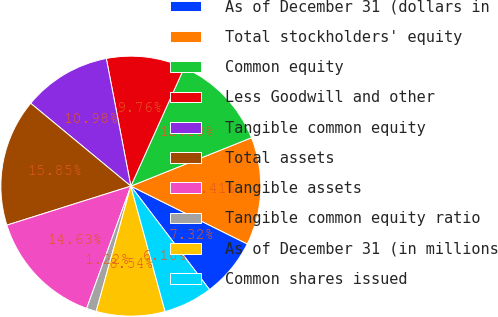Convert chart to OTSL. <chart><loc_0><loc_0><loc_500><loc_500><pie_chart><fcel>As of December 31 (dollars in<fcel>Total stockholders' equity<fcel>Common equity<fcel>Less Goodwill and other<fcel>Tangible common equity<fcel>Total assets<fcel>Tangible assets<fcel>Tangible common equity ratio<fcel>As of December 31 (in millions<fcel>Common shares issued<nl><fcel>7.32%<fcel>13.41%<fcel>12.19%<fcel>9.76%<fcel>10.98%<fcel>15.85%<fcel>14.63%<fcel>1.22%<fcel>8.54%<fcel>6.1%<nl></chart> 